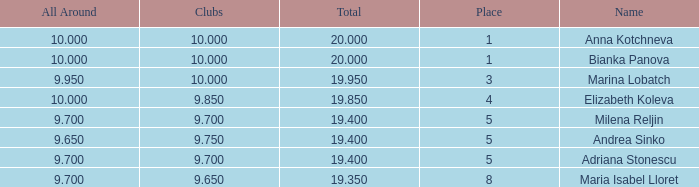What is the highest total that has andrea sinko as the name, with an all around greater than 9.65? None. 